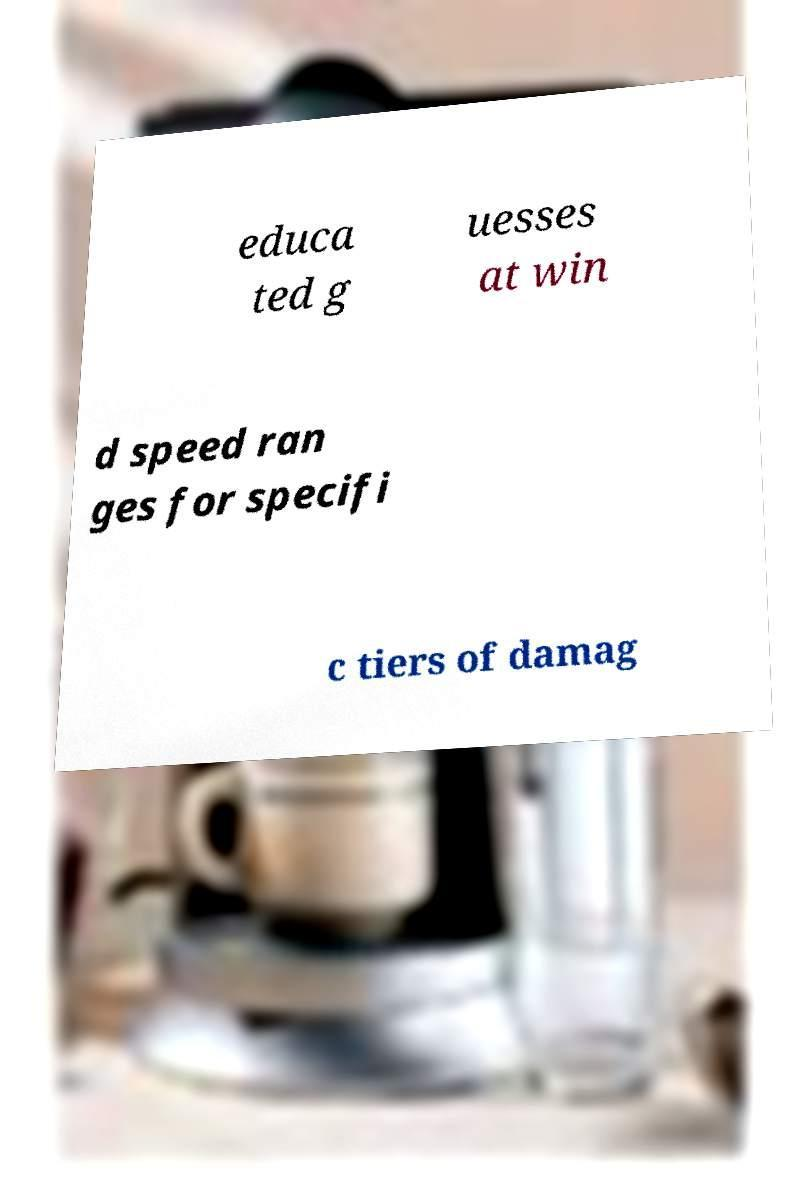Could you assist in decoding the text presented in this image and type it out clearly? educa ted g uesses at win d speed ran ges for specifi c tiers of damag 